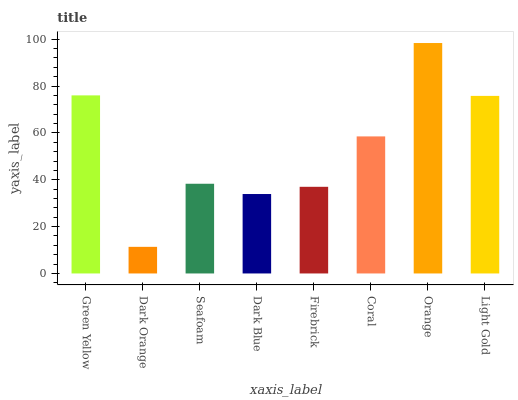Is Dark Orange the minimum?
Answer yes or no. Yes. Is Orange the maximum?
Answer yes or no. Yes. Is Seafoam the minimum?
Answer yes or no. No. Is Seafoam the maximum?
Answer yes or no. No. Is Seafoam greater than Dark Orange?
Answer yes or no. Yes. Is Dark Orange less than Seafoam?
Answer yes or no. Yes. Is Dark Orange greater than Seafoam?
Answer yes or no. No. Is Seafoam less than Dark Orange?
Answer yes or no. No. Is Coral the high median?
Answer yes or no. Yes. Is Seafoam the low median?
Answer yes or no. Yes. Is Dark Orange the high median?
Answer yes or no. No. Is Orange the low median?
Answer yes or no. No. 